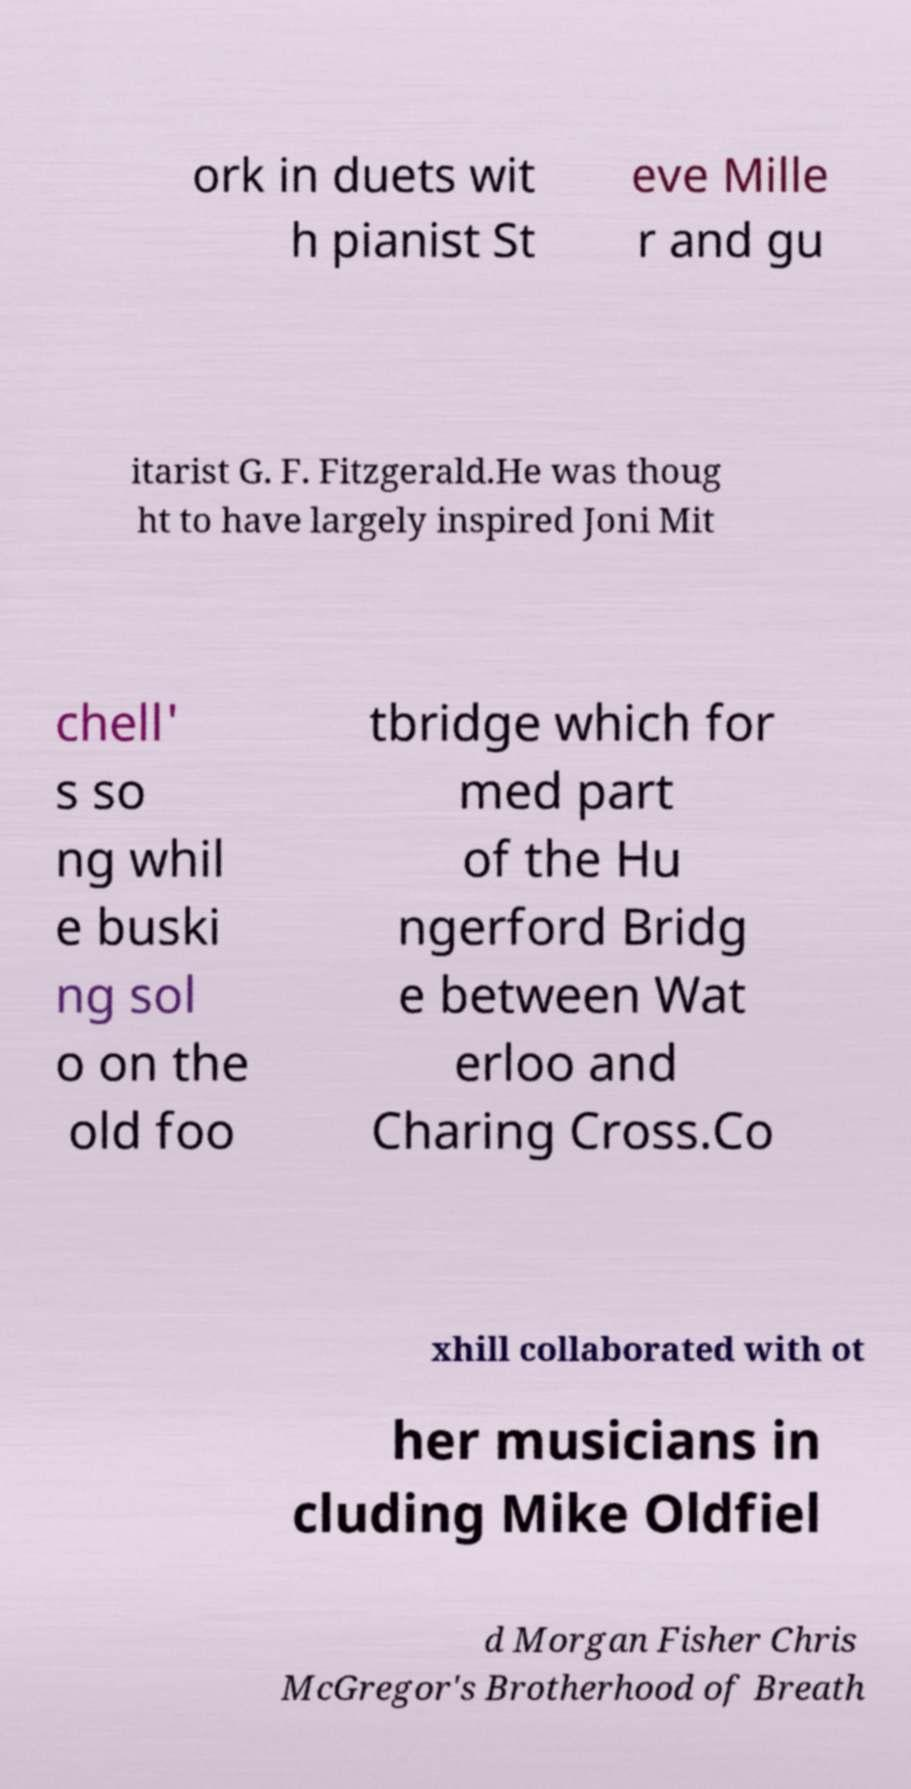Could you extract and type out the text from this image? ork in duets wit h pianist St eve Mille r and gu itarist G. F. Fitzgerald.He was thoug ht to have largely inspired Joni Mit chell' s so ng whil e buski ng sol o on the old foo tbridge which for med part of the Hu ngerford Bridg e between Wat erloo and Charing Cross.Co xhill collaborated with ot her musicians in cluding Mike Oldfiel d Morgan Fisher Chris McGregor's Brotherhood of Breath 